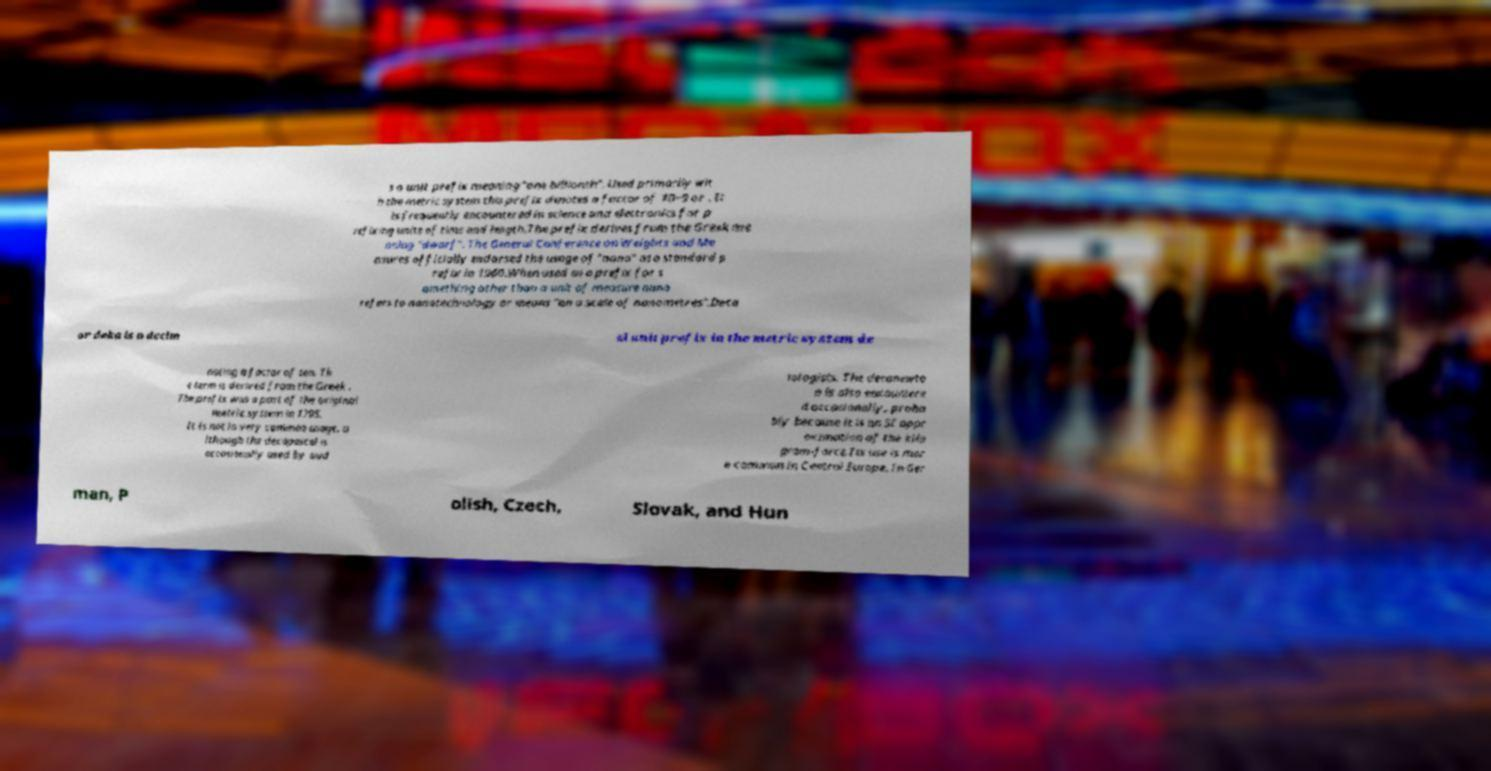There's text embedded in this image that I need extracted. Can you transcribe it verbatim? s a unit prefix meaning "one billionth". Used primarily wit h the metric system this prefix denotes a factor of 10−9 or . It is frequently encountered in science and electronics for p refixing units of time and length.The prefix derives from the Greek me aning "dwarf". The General Conference on Weights and Me asures officially endorsed the usage of "nano" as a standard p refix in 1960.When used as a prefix for s omething other than a unit of measure nano refers to nanotechnology or means "on a scale of nanometres".Deca or deka is a decim al unit prefix in the metric system de noting a factor of ten. Th e term is derived from the Greek . The prefix was a part of the original metric system in 1795. It is not in very common usage, a lthough the decapascal is occasionally used by aud iologists. The decanewto n is also encountere d occasionally, proba bly because it is an SI appr oximation of the kilo gram-force.Its use is mor e common in Central Europe. In Ger man, P olish, Czech, Slovak, and Hun 